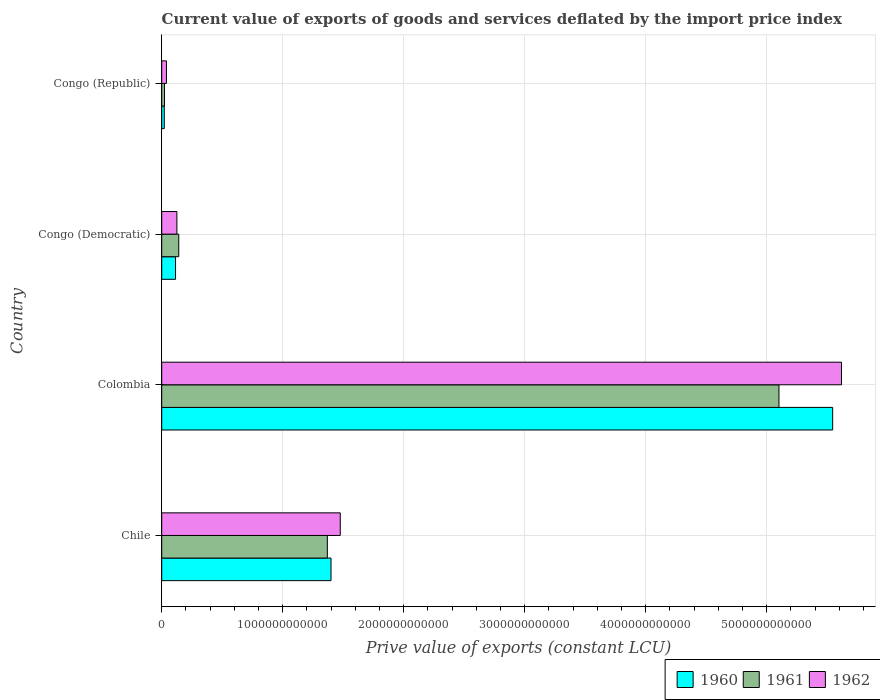How many different coloured bars are there?
Your answer should be very brief. 3. Are the number of bars per tick equal to the number of legend labels?
Your answer should be compact. Yes. How many bars are there on the 1st tick from the top?
Give a very brief answer. 3. What is the label of the 2nd group of bars from the top?
Offer a terse response. Congo (Democratic). What is the prive value of exports in 1961 in Congo (Democratic)?
Offer a very short reply. 1.41e+11. Across all countries, what is the maximum prive value of exports in 1962?
Ensure brevity in your answer.  5.62e+12. Across all countries, what is the minimum prive value of exports in 1962?
Your answer should be compact. 3.92e+1. In which country was the prive value of exports in 1960 minimum?
Your answer should be compact. Congo (Republic). What is the total prive value of exports in 1960 in the graph?
Offer a terse response. 7.08e+12. What is the difference between the prive value of exports in 1962 in Chile and that in Congo (Republic)?
Your answer should be very brief. 1.44e+12. What is the difference between the prive value of exports in 1960 in Congo (Republic) and the prive value of exports in 1962 in Congo (Democratic)?
Provide a succinct answer. -1.04e+11. What is the average prive value of exports in 1961 per country?
Make the answer very short. 1.66e+12. What is the difference between the prive value of exports in 1961 and prive value of exports in 1962 in Colombia?
Give a very brief answer. -5.17e+11. What is the ratio of the prive value of exports in 1962 in Chile to that in Colombia?
Your response must be concise. 0.26. Is the prive value of exports in 1962 in Chile less than that in Congo (Republic)?
Provide a short and direct response. No. Is the difference between the prive value of exports in 1961 in Colombia and Congo (Republic) greater than the difference between the prive value of exports in 1962 in Colombia and Congo (Republic)?
Ensure brevity in your answer.  No. What is the difference between the highest and the second highest prive value of exports in 1962?
Offer a terse response. 4.14e+12. What is the difference between the highest and the lowest prive value of exports in 1962?
Your response must be concise. 5.58e+12. What does the 3rd bar from the bottom in Chile represents?
Your answer should be very brief. 1962. How many bars are there?
Your response must be concise. 12. What is the difference between two consecutive major ticks on the X-axis?
Provide a succinct answer. 1.00e+12. Where does the legend appear in the graph?
Your answer should be compact. Bottom right. How many legend labels are there?
Offer a very short reply. 3. How are the legend labels stacked?
Your response must be concise. Horizontal. What is the title of the graph?
Provide a short and direct response. Current value of exports of goods and services deflated by the import price index. What is the label or title of the X-axis?
Keep it short and to the point. Prive value of exports (constant LCU). What is the Prive value of exports (constant LCU) in 1960 in Chile?
Your answer should be compact. 1.40e+12. What is the Prive value of exports (constant LCU) in 1961 in Chile?
Provide a succinct answer. 1.37e+12. What is the Prive value of exports (constant LCU) in 1962 in Chile?
Make the answer very short. 1.48e+12. What is the Prive value of exports (constant LCU) in 1960 in Colombia?
Your response must be concise. 5.54e+12. What is the Prive value of exports (constant LCU) in 1961 in Colombia?
Provide a succinct answer. 5.10e+12. What is the Prive value of exports (constant LCU) of 1962 in Colombia?
Your answer should be compact. 5.62e+12. What is the Prive value of exports (constant LCU) of 1960 in Congo (Democratic)?
Offer a terse response. 1.14e+11. What is the Prive value of exports (constant LCU) in 1961 in Congo (Democratic)?
Offer a very short reply. 1.41e+11. What is the Prive value of exports (constant LCU) of 1962 in Congo (Democratic)?
Offer a terse response. 1.25e+11. What is the Prive value of exports (constant LCU) of 1960 in Congo (Republic)?
Ensure brevity in your answer.  2.11e+1. What is the Prive value of exports (constant LCU) in 1961 in Congo (Republic)?
Your response must be concise. 2.29e+1. What is the Prive value of exports (constant LCU) in 1962 in Congo (Republic)?
Provide a short and direct response. 3.92e+1. Across all countries, what is the maximum Prive value of exports (constant LCU) of 1960?
Your answer should be compact. 5.54e+12. Across all countries, what is the maximum Prive value of exports (constant LCU) of 1961?
Provide a succinct answer. 5.10e+12. Across all countries, what is the maximum Prive value of exports (constant LCU) of 1962?
Offer a terse response. 5.62e+12. Across all countries, what is the minimum Prive value of exports (constant LCU) of 1960?
Offer a terse response. 2.11e+1. Across all countries, what is the minimum Prive value of exports (constant LCU) of 1961?
Your answer should be compact. 2.29e+1. Across all countries, what is the minimum Prive value of exports (constant LCU) in 1962?
Provide a short and direct response. 3.92e+1. What is the total Prive value of exports (constant LCU) of 1960 in the graph?
Give a very brief answer. 7.08e+12. What is the total Prive value of exports (constant LCU) in 1961 in the graph?
Provide a succinct answer. 6.63e+12. What is the total Prive value of exports (constant LCU) of 1962 in the graph?
Your answer should be compact. 7.26e+12. What is the difference between the Prive value of exports (constant LCU) in 1960 in Chile and that in Colombia?
Keep it short and to the point. -4.15e+12. What is the difference between the Prive value of exports (constant LCU) in 1961 in Chile and that in Colombia?
Give a very brief answer. -3.73e+12. What is the difference between the Prive value of exports (constant LCU) in 1962 in Chile and that in Colombia?
Keep it short and to the point. -4.14e+12. What is the difference between the Prive value of exports (constant LCU) of 1960 in Chile and that in Congo (Democratic)?
Keep it short and to the point. 1.28e+12. What is the difference between the Prive value of exports (constant LCU) of 1961 in Chile and that in Congo (Democratic)?
Give a very brief answer. 1.23e+12. What is the difference between the Prive value of exports (constant LCU) of 1962 in Chile and that in Congo (Democratic)?
Make the answer very short. 1.35e+12. What is the difference between the Prive value of exports (constant LCU) of 1960 in Chile and that in Congo (Republic)?
Keep it short and to the point. 1.38e+12. What is the difference between the Prive value of exports (constant LCU) of 1961 in Chile and that in Congo (Republic)?
Offer a terse response. 1.35e+12. What is the difference between the Prive value of exports (constant LCU) in 1962 in Chile and that in Congo (Republic)?
Keep it short and to the point. 1.44e+12. What is the difference between the Prive value of exports (constant LCU) in 1960 in Colombia and that in Congo (Democratic)?
Provide a short and direct response. 5.43e+12. What is the difference between the Prive value of exports (constant LCU) of 1961 in Colombia and that in Congo (Democratic)?
Offer a terse response. 4.96e+12. What is the difference between the Prive value of exports (constant LCU) of 1962 in Colombia and that in Congo (Democratic)?
Your answer should be compact. 5.49e+12. What is the difference between the Prive value of exports (constant LCU) in 1960 in Colombia and that in Congo (Republic)?
Provide a succinct answer. 5.52e+12. What is the difference between the Prive value of exports (constant LCU) of 1961 in Colombia and that in Congo (Republic)?
Provide a succinct answer. 5.08e+12. What is the difference between the Prive value of exports (constant LCU) of 1962 in Colombia and that in Congo (Republic)?
Offer a very short reply. 5.58e+12. What is the difference between the Prive value of exports (constant LCU) of 1960 in Congo (Democratic) and that in Congo (Republic)?
Offer a very short reply. 9.32e+1. What is the difference between the Prive value of exports (constant LCU) of 1961 in Congo (Democratic) and that in Congo (Republic)?
Offer a very short reply. 1.18e+11. What is the difference between the Prive value of exports (constant LCU) of 1962 in Congo (Democratic) and that in Congo (Republic)?
Make the answer very short. 8.63e+1. What is the difference between the Prive value of exports (constant LCU) in 1960 in Chile and the Prive value of exports (constant LCU) in 1961 in Colombia?
Ensure brevity in your answer.  -3.70e+12. What is the difference between the Prive value of exports (constant LCU) of 1960 in Chile and the Prive value of exports (constant LCU) of 1962 in Colombia?
Keep it short and to the point. -4.22e+12. What is the difference between the Prive value of exports (constant LCU) of 1961 in Chile and the Prive value of exports (constant LCU) of 1962 in Colombia?
Keep it short and to the point. -4.25e+12. What is the difference between the Prive value of exports (constant LCU) of 1960 in Chile and the Prive value of exports (constant LCU) of 1961 in Congo (Democratic)?
Ensure brevity in your answer.  1.26e+12. What is the difference between the Prive value of exports (constant LCU) in 1960 in Chile and the Prive value of exports (constant LCU) in 1962 in Congo (Democratic)?
Provide a succinct answer. 1.27e+12. What is the difference between the Prive value of exports (constant LCU) of 1961 in Chile and the Prive value of exports (constant LCU) of 1962 in Congo (Democratic)?
Offer a very short reply. 1.24e+12. What is the difference between the Prive value of exports (constant LCU) of 1960 in Chile and the Prive value of exports (constant LCU) of 1961 in Congo (Republic)?
Offer a terse response. 1.38e+12. What is the difference between the Prive value of exports (constant LCU) in 1960 in Chile and the Prive value of exports (constant LCU) in 1962 in Congo (Republic)?
Provide a short and direct response. 1.36e+12. What is the difference between the Prive value of exports (constant LCU) in 1961 in Chile and the Prive value of exports (constant LCU) in 1962 in Congo (Republic)?
Offer a very short reply. 1.33e+12. What is the difference between the Prive value of exports (constant LCU) of 1960 in Colombia and the Prive value of exports (constant LCU) of 1961 in Congo (Democratic)?
Keep it short and to the point. 5.40e+12. What is the difference between the Prive value of exports (constant LCU) in 1960 in Colombia and the Prive value of exports (constant LCU) in 1962 in Congo (Democratic)?
Keep it short and to the point. 5.42e+12. What is the difference between the Prive value of exports (constant LCU) in 1961 in Colombia and the Prive value of exports (constant LCU) in 1962 in Congo (Democratic)?
Offer a very short reply. 4.98e+12. What is the difference between the Prive value of exports (constant LCU) of 1960 in Colombia and the Prive value of exports (constant LCU) of 1961 in Congo (Republic)?
Your answer should be very brief. 5.52e+12. What is the difference between the Prive value of exports (constant LCU) of 1960 in Colombia and the Prive value of exports (constant LCU) of 1962 in Congo (Republic)?
Give a very brief answer. 5.51e+12. What is the difference between the Prive value of exports (constant LCU) in 1961 in Colombia and the Prive value of exports (constant LCU) in 1962 in Congo (Republic)?
Keep it short and to the point. 5.06e+12. What is the difference between the Prive value of exports (constant LCU) in 1960 in Congo (Democratic) and the Prive value of exports (constant LCU) in 1961 in Congo (Republic)?
Offer a terse response. 9.15e+1. What is the difference between the Prive value of exports (constant LCU) of 1960 in Congo (Democratic) and the Prive value of exports (constant LCU) of 1962 in Congo (Republic)?
Offer a very short reply. 7.51e+1. What is the difference between the Prive value of exports (constant LCU) of 1961 in Congo (Democratic) and the Prive value of exports (constant LCU) of 1962 in Congo (Republic)?
Your answer should be very brief. 1.02e+11. What is the average Prive value of exports (constant LCU) in 1960 per country?
Provide a succinct answer. 1.77e+12. What is the average Prive value of exports (constant LCU) in 1961 per country?
Your answer should be very brief. 1.66e+12. What is the average Prive value of exports (constant LCU) in 1962 per country?
Offer a terse response. 1.81e+12. What is the difference between the Prive value of exports (constant LCU) of 1960 and Prive value of exports (constant LCU) of 1961 in Chile?
Keep it short and to the point. 3.03e+1. What is the difference between the Prive value of exports (constant LCU) in 1960 and Prive value of exports (constant LCU) in 1962 in Chile?
Offer a terse response. -7.65e+1. What is the difference between the Prive value of exports (constant LCU) in 1961 and Prive value of exports (constant LCU) in 1962 in Chile?
Give a very brief answer. -1.07e+11. What is the difference between the Prive value of exports (constant LCU) of 1960 and Prive value of exports (constant LCU) of 1961 in Colombia?
Make the answer very short. 4.44e+11. What is the difference between the Prive value of exports (constant LCU) of 1960 and Prive value of exports (constant LCU) of 1962 in Colombia?
Give a very brief answer. -7.31e+1. What is the difference between the Prive value of exports (constant LCU) in 1961 and Prive value of exports (constant LCU) in 1962 in Colombia?
Your answer should be very brief. -5.17e+11. What is the difference between the Prive value of exports (constant LCU) in 1960 and Prive value of exports (constant LCU) in 1961 in Congo (Democratic)?
Ensure brevity in your answer.  -2.65e+1. What is the difference between the Prive value of exports (constant LCU) of 1960 and Prive value of exports (constant LCU) of 1962 in Congo (Democratic)?
Provide a succinct answer. -1.11e+1. What is the difference between the Prive value of exports (constant LCU) in 1961 and Prive value of exports (constant LCU) in 1962 in Congo (Democratic)?
Provide a succinct answer. 1.54e+1. What is the difference between the Prive value of exports (constant LCU) in 1960 and Prive value of exports (constant LCU) in 1961 in Congo (Republic)?
Make the answer very short. -1.75e+09. What is the difference between the Prive value of exports (constant LCU) in 1960 and Prive value of exports (constant LCU) in 1962 in Congo (Republic)?
Ensure brevity in your answer.  -1.81e+1. What is the difference between the Prive value of exports (constant LCU) in 1961 and Prive value of exports (constant LCU) in 1962 in Congo (Republic)?
Ensure brevity in your answer.  -1.64e+1. What is the ratio of the Prive value of exports (constant LCU) in 1960 in Chile to that in Colombia?
Keep it short and to the point. 0.25. What is the ratio of the Prive value of exports (constant LCU) in 1961 in Chile to that in Colombia?
Offer a terse response. 0.27. What is the ratio of the Prive value of exports (constant LCU) in 1962 in Chile to that in Colombia?
Offer a terse response. 0.26. What is the ratio of the Prive value of exports (constant LCU) in 1960 in Chile to that in Congo (Democratic)?
Offer a terse response. 12.24. What is the ratio of the Prive value of exports (constant LCU) of 1961 in Chile to that in Congo (Democratic)?
Provide a succinct answer. 9.71. What is the ratio of the Prive value of exports (constant LCU) in 1962 in Chile to that in Congo (Democratic)?
Your response must be concise. 11.76. What is the ratio of the Prive value of exports (constant LCU) of 1960 in Chile to that in Congo (Republic)?
Offer a terse response. 66.28. What is the ratio of the Prive value of exports (constant LCU) in 1961 in Chile to that in Congo (Republic)?
Provide a short and direct response. 59.88. What is the ratio of the Prive value of exports (constant LCU) of 1962 in Chile to that in Congo (Republic)?
Offer a terse response. 37.62. What is the ratio of the Prive value of exports (constant LCU) of 1960 in Colombia to that in Congo (Democratic)?
Offer a terse response. 48.49. What is the ratio of the Prive value of exports (constant LCU) of 1961 in Colombia to that in Congo (Democratic)?
Ensure brevity in your answer.  36.21. What is the ratio of the Prive value of exports (constant LCU) of 1962 in Colombia to that in Congo (Democratic)?
Give a very brief answer. 44.77. What is the ratio of the Prive value of exports (constant LCU) in 1960 in Colombia to that in Congo (Republic)?
Ensure brevity in your answer.  262.67. What is the ratio of the Prive value of exports (constant LCU) of 1961 in Colombia to that in Congo (Republic)?
Keep it short and to the point. 223.16. What is the ratio of the Prive value of exports (constant LCU) in 1962 in Colombia to that in Congo (Republic)?
Give a very brief answer. 143.22. What is the ratio of the Prive value of exports (constant LCU) in 1960 in Congo (Democratic) to that in Congo (Republic)?
Offer a terse response. 5.42. What is the ratio of the Prive value of exports (constant LCU) of 1961 in Congo (Democratic) to that in Congo (Republic)?
Your response must be concise. 6.16. What is the ratio of the Prive value of exports (constant LCU) in 1962 in Congo (Democratic) to that in Congo (Republic)?
Ensure brevity in your answer.  3.2. What is the difference between the highest and the second highest Prive value of exports (constant LCU) in 1960?
Provide a succinct answer. 4.15e+12. What is the difference between the highest and the second highest Prive value of exports (constant LCU) in 1961?
Ensure brevity in your answer.  3.73e+12. What is the difference between the highest and the second highest Prive value of exports (constant LCU) in 1962?
Make the answer very short. 4.14e+12. What is the difference between the highest and the lowest Prive value of exports (constant LCU) in 1960?
Give a very brief answer. 5.52e+12. What is the difference between the highest and the lowest Prive value of exports (constant LCU) of 1961?
Your response must be concise. 5.08e+12. What is the difference between the highest and the lowest Prive value of exports (constant LCU) of 1962?
Give a very brief answer. 5.58e+12. 